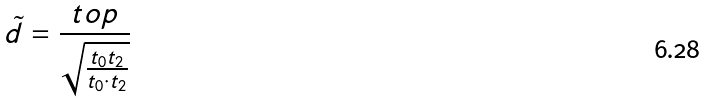<formula> <loc_0><loc_0><loc_500><loc_500>\tilde { d } = \frac { t o p } { \sqrt { \frac { t _ { 0 } t _ { 2 } } { t _ { 0 } \cdot t _ { 2 } } } }</formula> 